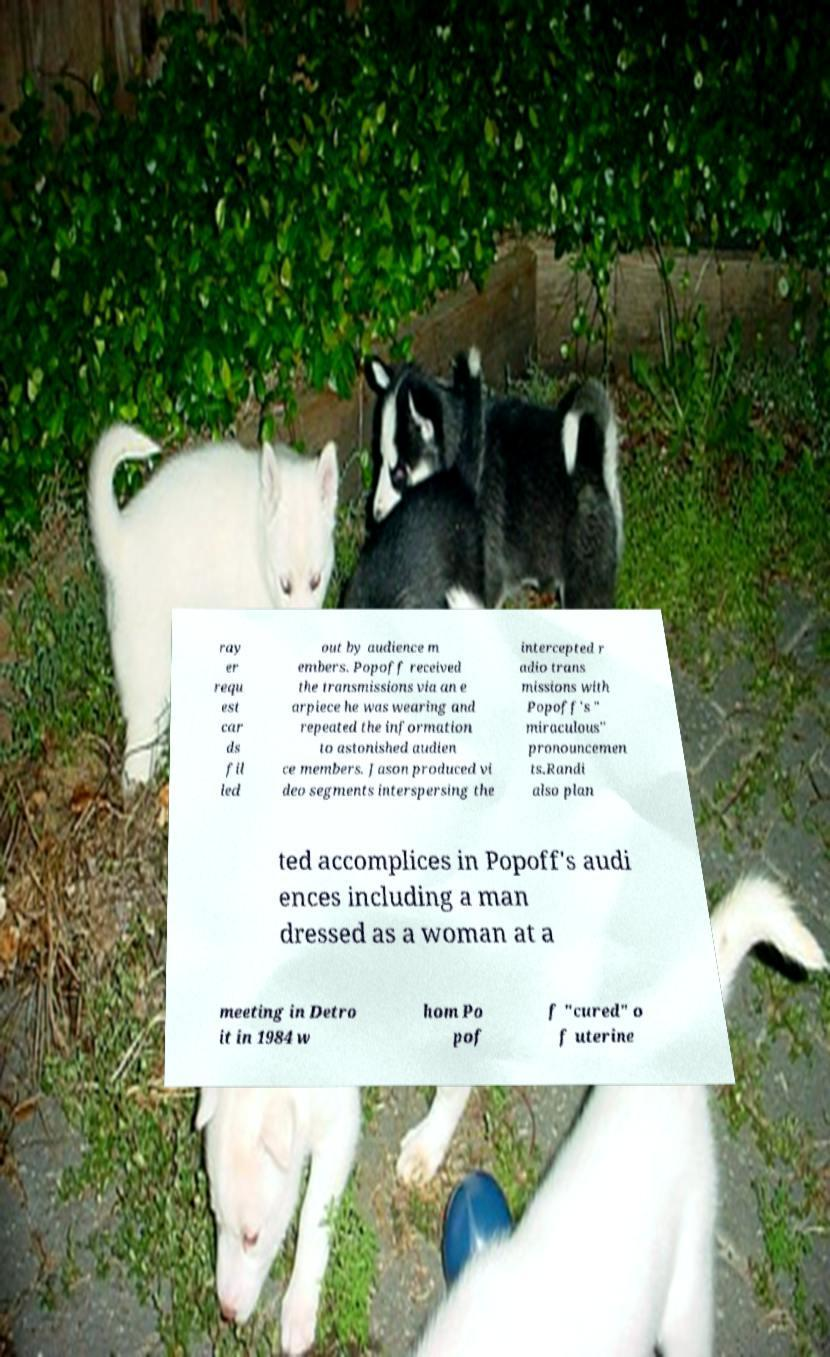Could you extract and type out the text from this image? ray er requ est car ds fil led out by audience m embers. Popoff received the transmissions via an e arpiece he was wearing and repeated the information to astonished audien ce members. Jason produced vi deo segments interspersing the intercepted r adio trans missions with Popoff's " miraculous" pronouncemen ts.Randi also plan ted accomplices in Popoff's audi ences including a man dressed as a woman at a meeting in Detro it in 1984 w hom Po pof f "cured" o f uterine 